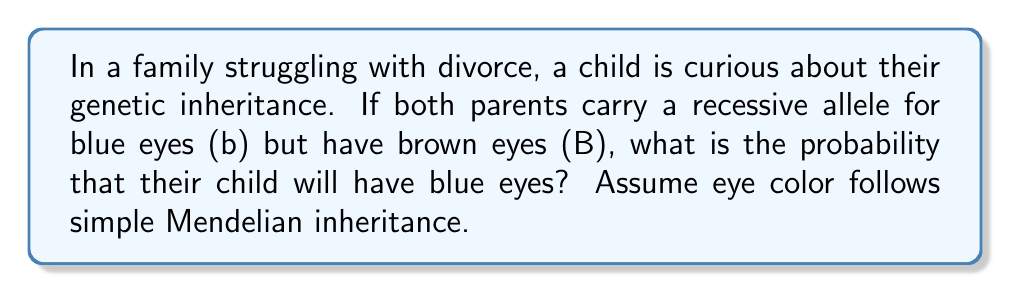Show me your answer to this math problem. Let's approach this step-by-step:

1) First, we need to understand the genotypes of the parents. Both parents have brown eyes but carry a recessive allele for blue eyes. This means their genotype is Bb (heterozygous).

2) The possible gametes each parent can produce are:
   - B (dominant allele for brown eyes)
   - b (recessive allele for blue eyes)

3) We can use a Punnett square to visualize the possible combinations:

   $$
   \begin{array}{c|c|c}
    & B & b \\
   \hline
   B & BB & Bb \\
   \hline
   b & Bb & bb \\
   \end{array}
   $$

4) From the Punnett square, we can see that:
   - 1/4 chance of BB (brown eyes)
   - 2/4 chance of Bb (brown eyes, carrier)
   - 1/4 chance of bb (blue eyes)

5) The probability of having blue eyes is the probability of getting the bb genotype, which is 1/4 or 0.25 or 25%.

This genetic inheritance problem can serve as a metaphor for the stability and predictability that the student might be seeking in their life during the challenging time of their parents' divorce.
Answer: The probability that the child will have blue eyes is $\frac{1}{4}$ or 0.25 or 25%. 